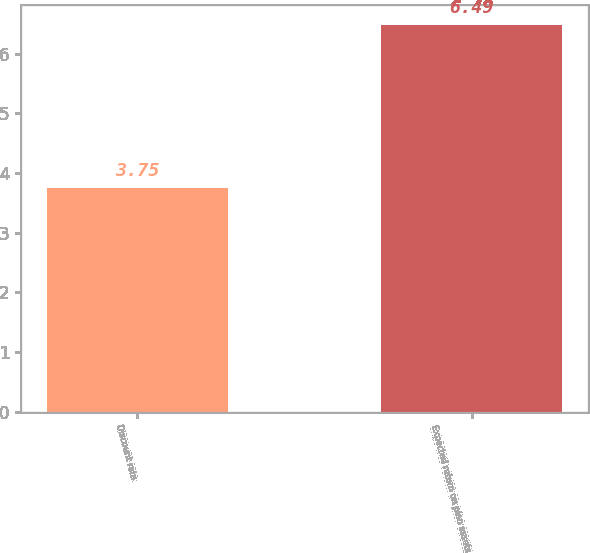Convert chart. <chart><loc_0><loc_0><loc_500><loc_500><bar_chart><fcel>Discount rate<fcel>Expected return on plan assets<nl><fcel>3.75<fcel>6.49<nl></chart> 